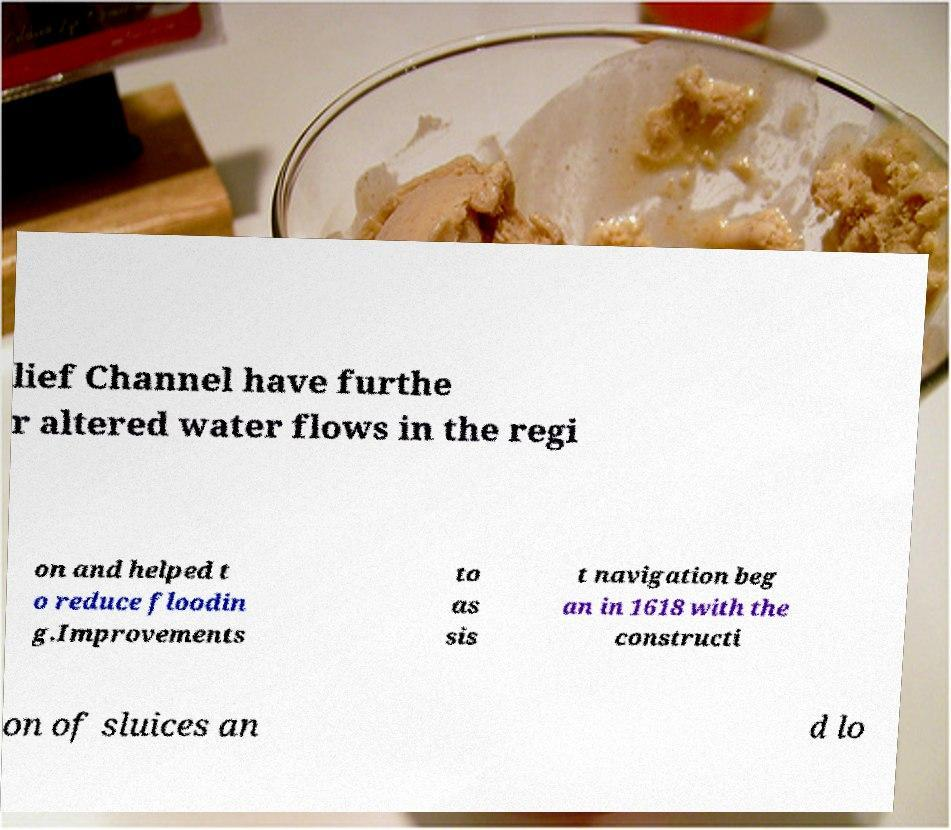Please read and relay the text visible in this image. What does it say? lief Channel have furthe r altered water flows in the regi on and helped t o reduce floodin g.Improvements to as sis t navigation beg an in 1618 with the constructi on of sluices an d lo 